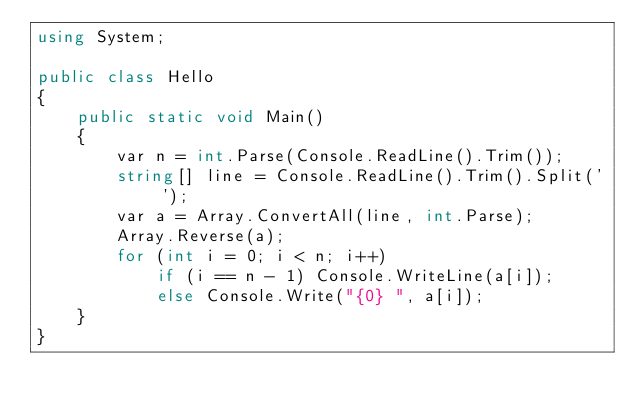<code> <loc_0><loc_0><loc_500><loc_500><_C#_>using System;

public class Hello
{
    public static void Main()
    {
        var n = int.Parse(Console.ReadLine().Trim());
        string[] line = Console.ReadLine().Trim().Split(' ');
        var a = Array.ConvertAll(line, int.Parse);
        Array.Reverse(a);
        for (int i = 0; i < n; i++)
            if (i == n - 1) Console.WriteLine(a[i]);
            else Console.Write("{0} ", a[i]);
    }
}

</code> 